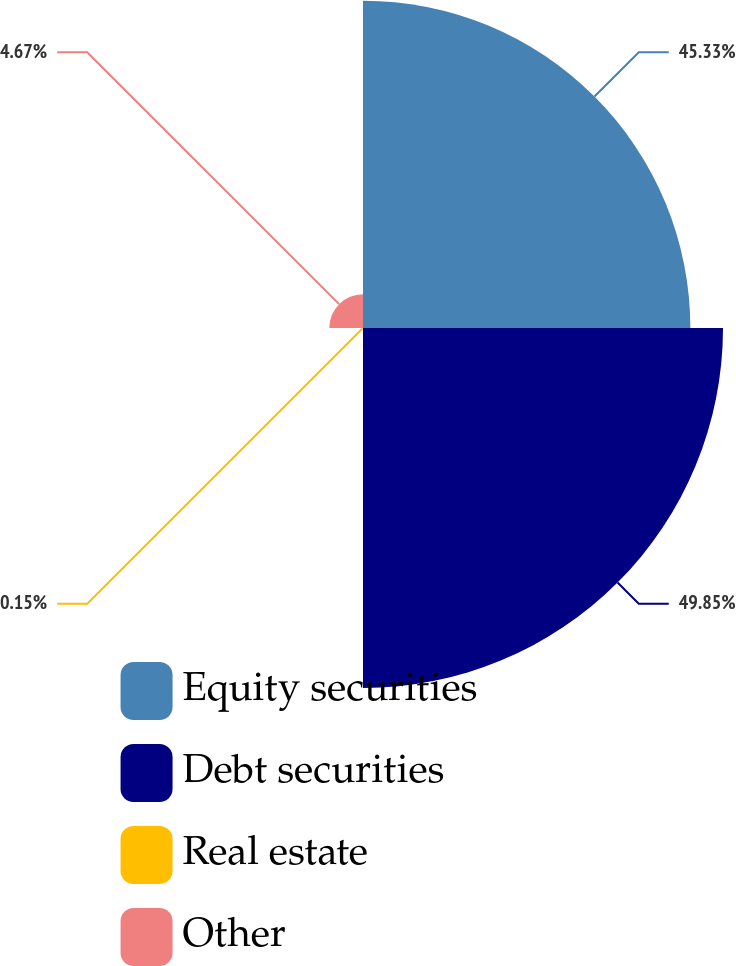Convert chart. <chart><loc_0><loc_0><loc_500><loc_500><pie_chart><fcel>Equity securities<fcel>Debt securities<fcel>Real estate<fcel>Other<nl><fcel>45.33%<fcel>49.85%<fcel>0.15%<fcel>4.67%<nl></chart> 